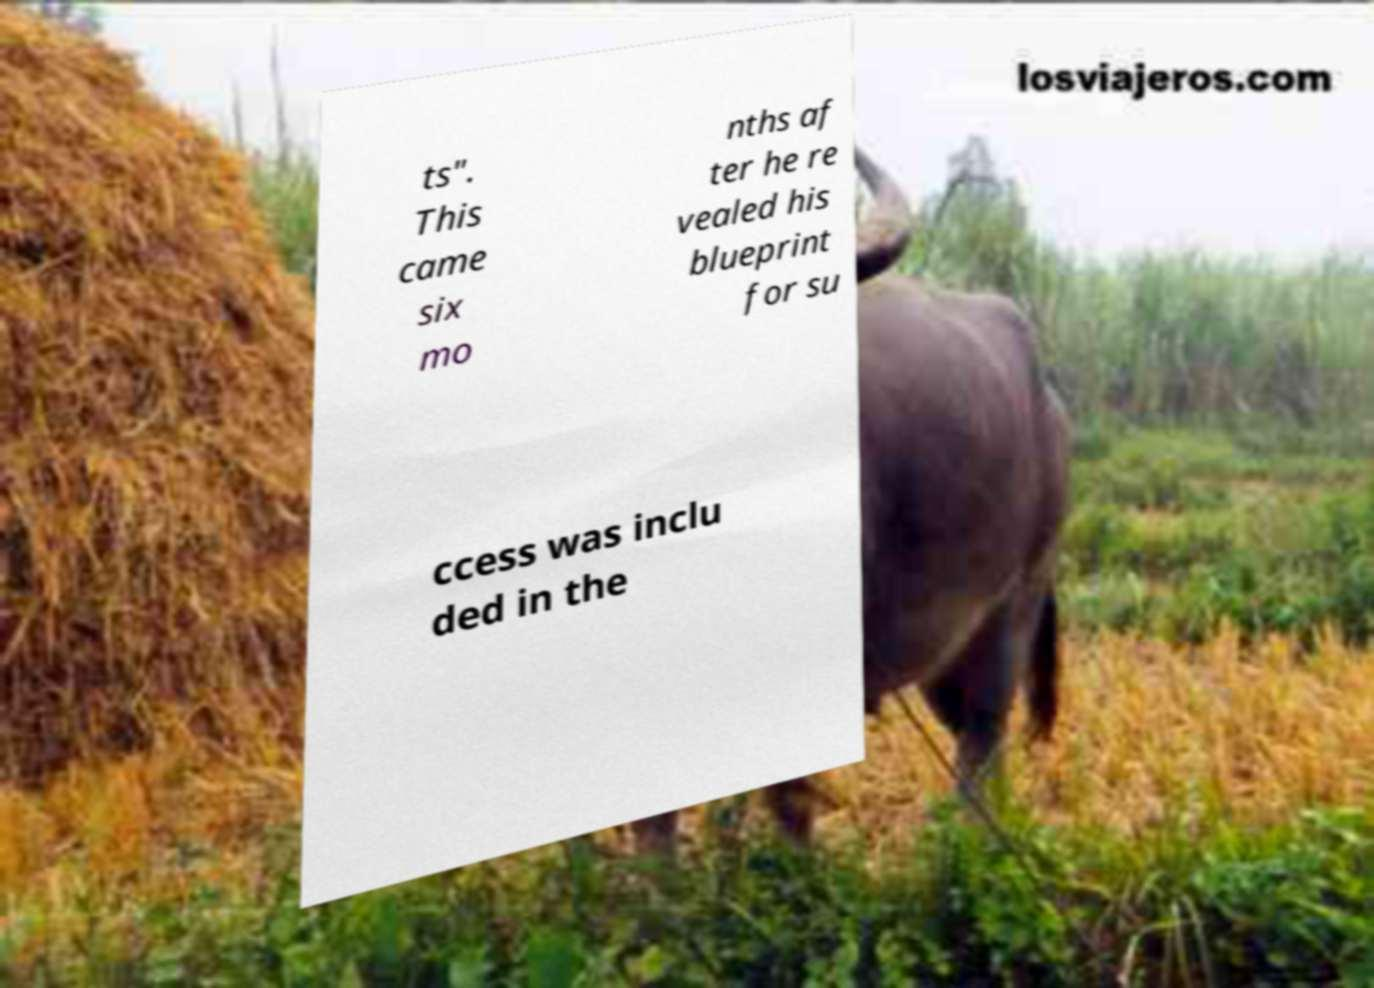For documentation purposes, I need the text within this image transcribed. Could you provide that? ts". This came six mo nths af ter he re vealed his blueprint for su ccess was inclu ded in the 